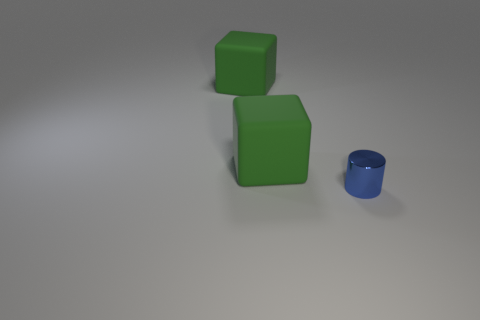Add 3 cubes. How many objects exist? 6 Subtract all cubes. How many objects are left? 1 Subtract 0 purple balls. How many objects are left? 3 Subtract all blue things. Subtract all small blue metal things. How many objects are left? 1 Add 1 green rubber cubes. How many green rubber cubes are left? 3 Add 2 large matte blocks. How many large matte blocks exist? 4 